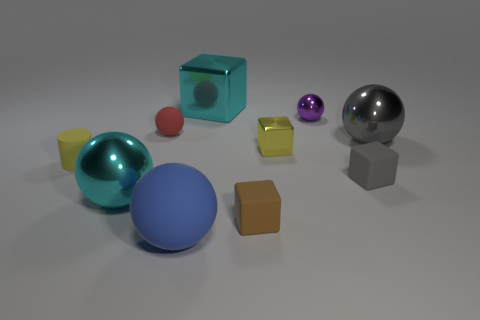There is a metallic thing that is on the right side of the cyan ball and in front of the gray metal sphere; what shape is it?
Give a very brief answer. Cube. Is there a small purple matte cylinder?
Give a very brief answer. No. What is the material of the small red object that is the same shape as the blue object?
Offer a terse response. Rubber. The yellow object to the left of the cyan metallic thing in front of the gray ball that is to the right of the big rubber thing is what shape?
Offer a terse response. Cylinder. What material is the tiny block that is the same color as the small rubber cylinder?
Your response must be concise. Metal. What number of big gray things have the same shape as the small yellow metallic thing?
Provide a succinct answer. 0. There is a rubber sphere that is behind the small yellow cylinder; is its color the same as the tiny cube behind the tiny yellow rubber cylinder?
Offer a very short reply. No. What material is the brown cube that is the same size as the yellow cube?
Your response must be concise. Rubber. Is there a yellow cylinder that has the same size as the cyan cube?
Provide a succinct answer. No. Are there fewer yellow matte cylinders that are behind the yellow metallic thing than small gray metal objects?
Your answer should be compact. No. 